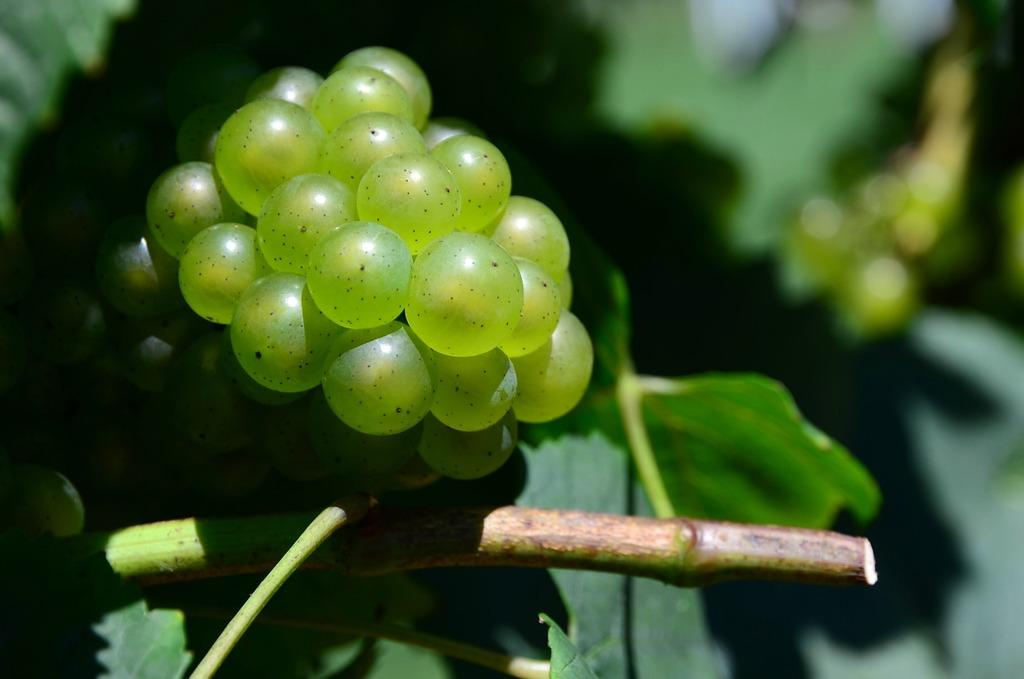What color are the fruits on the plant in the image? The fruits on the plant are green. Can you describe the background of the image? The background of the image is blurred. What type of iron is being used for scientific experiments in the image? There is no iron or scientific experiments present in the image; it features green color fruits on a plant with a blurred background. 